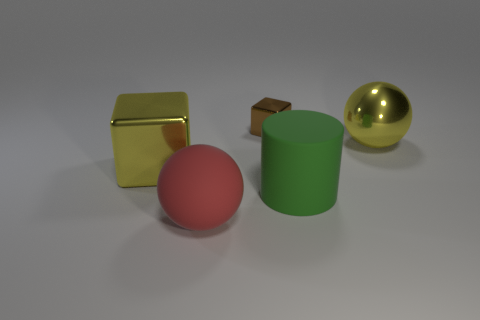Add 4 tiny rubber cylinders. How many objects exist? 9 Subtract all cylinders. How many objects are left? 4 Add 2 red rubber objects. How many red rubber objects are left? 3 Add 5 large red matte balls. How many large red matte balls exist? 6 Subtract 0 yellow cylinders. How many objects are left? 5 Subtract all large yellow shiny objects. Subtract all green rubber balls. How many objects are left? 3 